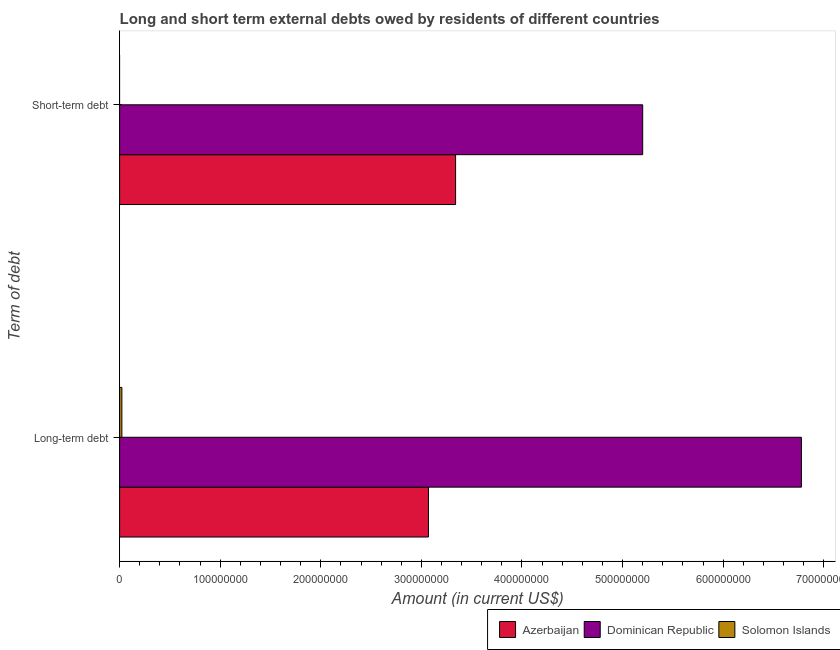How many groups of bars are there?
Make the answer very short. 2. Are the number of bars per tick equal to the number of legend labels?
Keep it short and to the point. No. Are the number of bars on each tick of the Y-axis equal?
Your response must be concise. No. How many bars are there on the 2nd tick from the top?
Your response must be concise. 3. What is the label of the 1st group of bars from the top?
Give a very brief answer. Short-term debt. What is the short-term debts owed by residents in Azerbaijan?
Give a very brief answer. 3.34e+08. Across all countries, what is the maximum long-term debts owed by residents?
Offer a terse response. 6.78e+08. Across all countries, what is the minimum long-term debts owed by residents?
Your response must be concise. 2.25e+06. In which country was the long-term debts owed by residents maximum?
Your answer should be compact. Dominican Republic. What is the total short-term debts owed by residents in the graph?
Your answer should be very brief. 8.54e+08. What is the difference between the long-term debts owed by residents in Solomon Islands and that in Azerbaijan?
Ensure brevity in your answer.  -3.05e+08. What is the difference between the short-term debts owed by residents in Dominican Republic and the long-term debts owed by residents in Azerbaijan?
Your response must be concise. 2.13e+08. What is the average short-term debts owed by residents per country?
Your answer should be compact. 2.85e+08. What is the difference between the short-term debts owed by residents and long-term debts owed by residents in Dominican Republic?
Your response must be concise. -1.58e+08. What is the ratio of the long-term debts owed by residents in Dominican Republic to that in Solomon Islands?
Your response must be concise. 301.64. How many countries are there in the graph?
Ensure brevity in your answer.  3. Are the values on the major ticks of X-axis written in scientific E-notation?
Give a very brief answer. No. Does the graph contain grids?
Your answer should be compact. No. Where does the legend appear in the graph?
Offer a terse response. Bottom right. How many legend labels are there?
Offer a very short reply. 3. How are the legend labels stacked?
Provide a succinct answer. Horizontal. What is the title of the graph?
Provide a succinct answer. Long and short term external debts owed by residents of different countries. What is the label or title of the X-axis?
Keep it short and to the point. Amount (in current US$). What is the label or title of the Y-axis?
Provide a short and direct response. Term of debt. What is the Amount (in current US$) in Azerbaijan in Long-term debt?
Provide a succinct answer. 3.07e+08. What is the Amount (in current US$) in Dominican Republic in Long-term debt?
Keep it short and to the point. 6.78e+08. What is the Amount (in current US$) in Solomon Islands in Long-term debt?
Make the answer very short. 2.25e+06. What is the Amount (in current US$) in Azerbaijan in Short-term debt?
Offer a terse response. 3.34e+08. What is the Amount (in current US$) in Dominican Republic in Short-term debt?
Offer a very short reply. 5.20e+08. Across all Term of debt, what is the maximum Amount (in current US$) of Azerbaijan?
Provide a succinct answer. 3.34e+08. Across all Term of debt, what is the maximum Amount (in current US$) in Dominican Republic?
Offer a terse response. 6.78e+08. Across all Term of debt, what is the maximum Amount (in current US$) of Solomon Islands?
Offer a terse response. 2.25e+06. Across all Term of debt, what is the minimum Amount (in current US$) in Azerbaijan?
Provide a short and direct response. 3.07e+08. Across all Term of debt, what is the minimum Amount (in current US$) of Dominican Republic?
Give a very brief answer. 5.20e+08. Across all Term of debt, what is the minimum Amount (in current US$) in Solomon Islands?
Offer a terse response. 0. What is the total Amount (in current US$) in Azerbaijan in the graph?
Provide a succinct answer. 6.41e+08. What is the total Amount (in current US$) of Dominican Republic in the graph?
Offer a terse response. 1.20e+09. What is the total Amount (in current US$) of Solomon Islands in the graph?
Keep it short and to the point. 2.25e+06. What is the difference between the Amount (in current US$) in Azerbaijan in Long-term debt and that in Short-term debt?
Provide a short and direct response. -2.70e+07. What is the difference between the Amount (in current US$) in Dominican Republic in Long-term debt and that in Short-term debt?
Offer a very short reply. 1.58e+08. What is the difference between the Amount (in current US$) in Azerbaijan in Long-term debt and the Amount (in current US$) in Dominican Republic in Short-term debt?
Keep it short and to the point. -2.13e+08. What is the average Amount (in current US$) in Azerbaijan per Term of debt?
Your response must be concise. 3.21e+08. What is the average Amount (in current US$) in Dominican Republic per Term of debt?
Offer a very short reply. 5.99e+08. What is the average Amount (in current US$) of Solomon Islands per Term of debt?
Keep it short and to the point. 1.12e+06. What is the difference between the Amount (in current US$) of Azerbaijan and Amount (in current US$) of Dominican Republic in Long-term debt?
Your answer should be compact. -3.71e+08. What is the difference between the Amount (in current US$) in Azerbaijan and Amount (in current US$) in Solomon Islands in Long-term debt?
Your response must be concise. 3.05e+08. What is the difference between the Amount (in current US$) of Dominican Republic and Amount (in current US$) of Solomon Islands in Long-term debt?
Your response must be concise. 6.76e+08. What is the difference between the Amount (in current US$) of Azerbaijan and Amount (in current US$) of Dominican Republic in Short-term debt?
Give a very brief answer. -1.86e+08. What is the ratio of the Amount (in current US$) in Azerbaijan in Long-term debt to that in Short-term debt?
Keep it short and to the point. 0.92. What is the ratio of the Amount (in current US$) of Dominican Republic in Long-term debt to that in Short-term debt?
Provide a succinct answer. 1.3. What is the difference between the highest and the second highest Amount (in current US$) in Azerbaijan?
Your response must be concise. 2.70e+07. What is the difference between the highest and the second highest Amount (in current US$) of Dominican Republic?
Give a very brief answer. 1.58e+08. What is the difference between the highest and the lowest Amount (in current US$) in Azerbaijan?
Give a very brief answer. 2.70e+07. What is the difference between the highest and the lowest Amount (in current US$) of Dominican Republic?
Provide a succinct answer. 1.58e+08. What is the difference between the highest and the lowest Amount (in current US$) in Solomon Islands?
Ensure brevity in your answer.  2.25e+06. 